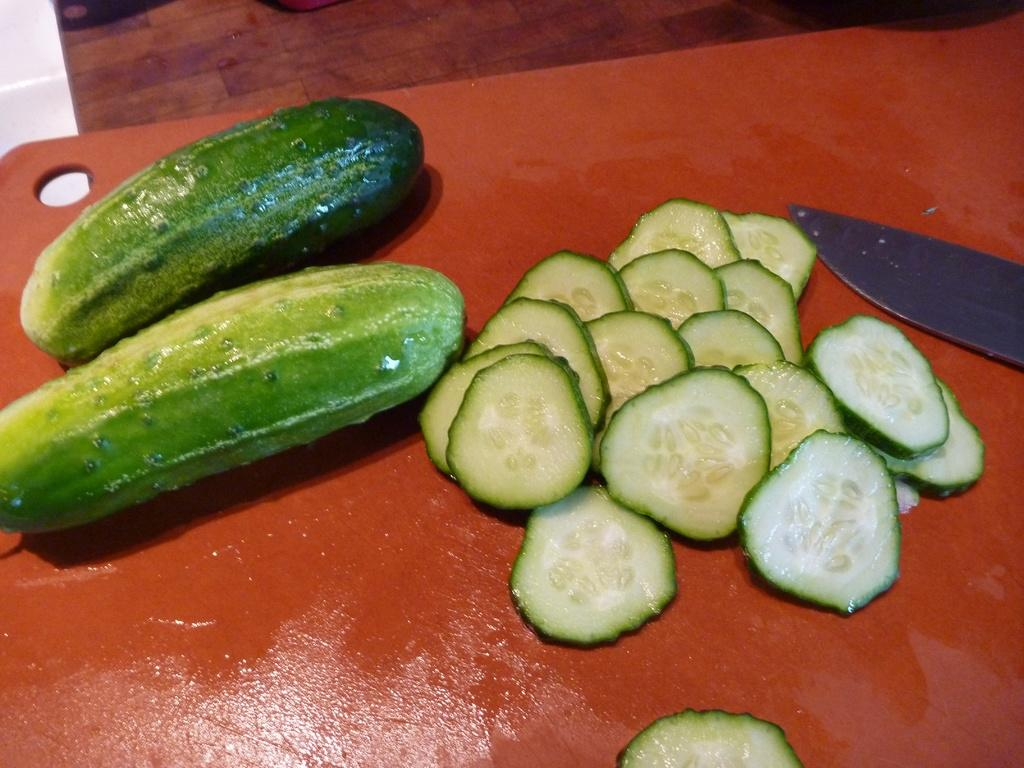What type of food is shown in the image? There are sliced pieces of food in the image. What kind of food can be identified from the sliced pieces? The sliced pieces are vegetables. What utensil is present in the image? There is a knife on a plate in the image. What trick is the son performing with the jar in the image? There is no trick, son, or jar present in the image. 